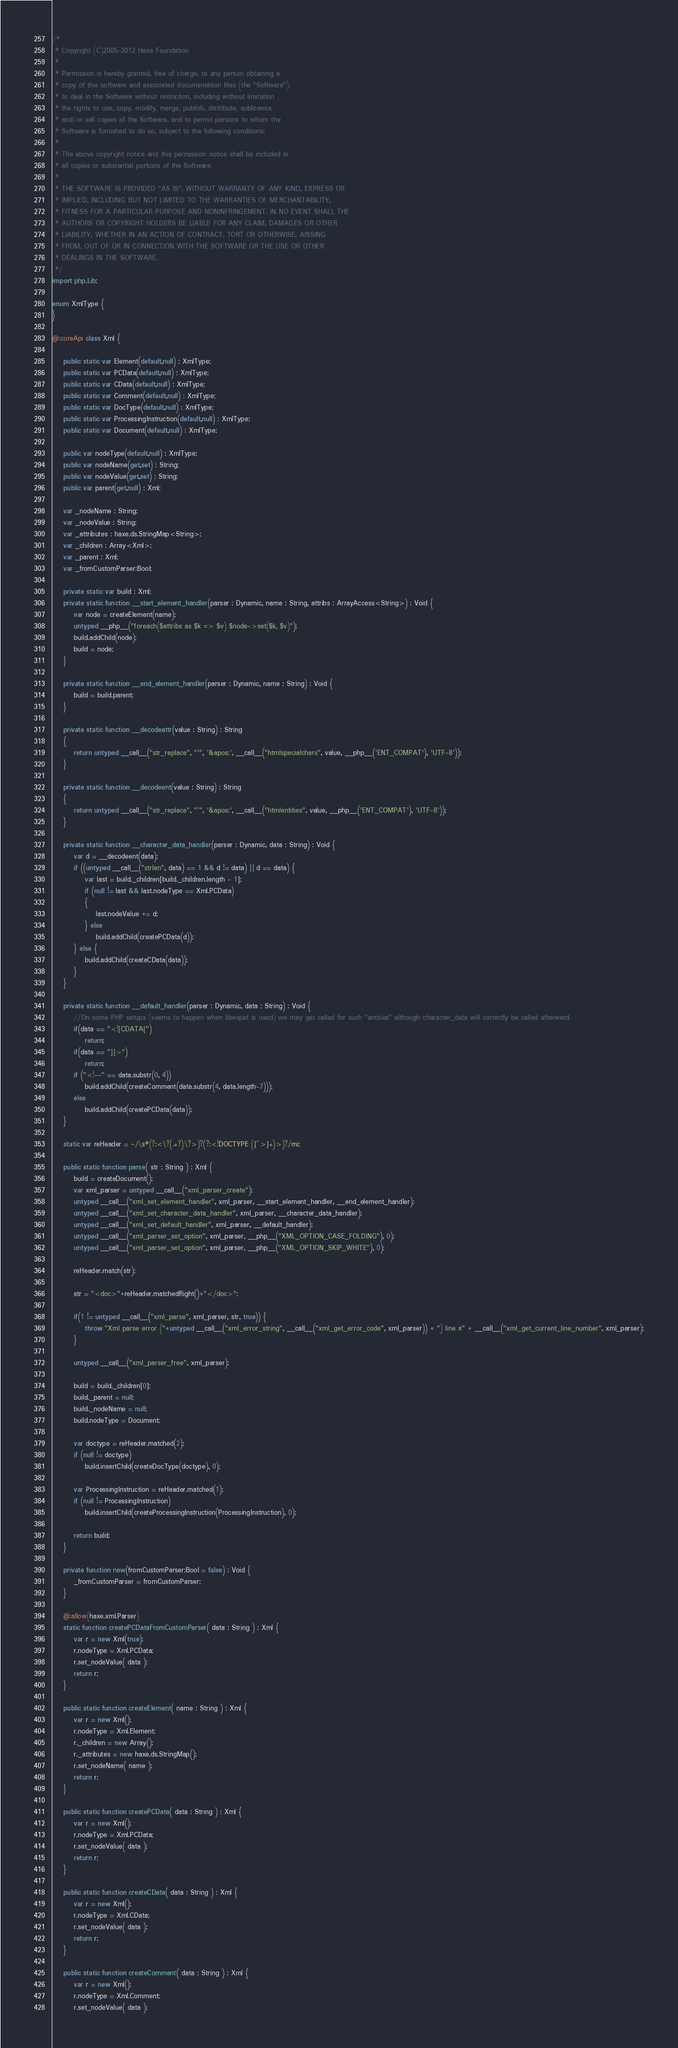<code> <loc_0><loc_0><loc_500><loc_500><_Haxe_>/*
 * Copyright (C)2005-2012 Haxe Foundation
 *
 * Permission is hereby granted, free of charge, to any person obtaining a
 * copy of this software and associated documentation files (the "Software"),
 * to deal in the Software without restriction, including without limitation
 * the rights to use, copy, modify, merge, publish, distribute, sublicense,
 * and/or sell copies of the Software, and to permit persons to whom the
 * Software is furnished to do so, subject to the following conditions:
 *
 * The above copyright notice and this permission notice shall be included in
 * all copies or substantial portions of the Software.
 *
 * THE SOFTWARE IS PROVIDED "AS IS", WITHOUT WARRANTY OF ANY KIND, EXPRESS OR
 * IMPLIED, INCLUDING BUT NOT LIMITED TO THE WARRANTIES OF MERCHANTABILITY,
 * FITNESS FOR A PARTICULAR PURPOSE AND NONINFRINGEMENT. IN NO EVENT SHALL THE
 * AUTHORS OR COPYRIGHT HOLDERS BE LIABLE FOR ANY CLAIM, DAMAGES OR OTHER
 * LIABILITY, WHETHER IN AN ACTION OF CONTRACT, TORT OR OTHERWISE, ARISING
 * FROM, OUT OF OR IN CONNECTION WITH THE SOFTWARE OR THE USE OR OTHER
 * DEALINGS IN THE SOFTWARE.
 */
import php.Lib;

enum XmlType {
}

@:coreApi class Xml {

	public static var Element(default,null) : XmlType;
	public static var PCData(default,null) : XmlType;
	public static var CData(default,null) : XmlType;
	public static var Comment(default,null) : XmlType;
	public static var DocType(default,null) : XmlType;
	public static var ProcessingInstruction(default,null) : XmlType;
	public static var Document(default,null) : XmlType;

	public var nodeType(default,null) : XmlType;
	public var nodeName(get,set) : String;
	public var nodeValue(get,set) : String;
	public var parent(get,null) : Xml;

	var _nodeName : String;
	var _nodeValue : String;
	var _attributes : haxe.ds.StringMap<String>;
	var _children : Array<Xml>;
	var _parent : Xml;
	var _fromCustomParser:Bool;

	private static var build : Xml;
	private static function __start_element_handler(parser : Dynamic, name : String, attribs : ArrayAccess<String>) : Void {
		var node = createElement(name);
		untyped __php__("foreach($attribs as $k => $v) $node->set($k, $v)");
		build.addChild(node);
		build = node;
	}

	private static function __end_element_handler(parser : Dynamic, name : String) : Void {
		build = build.parent;
	}

	private static function __decodeattr(value : String) : String
	{
		return untyped __call__("str_replace", "'", '&apos;', __call__("htmlspecialchars", value, __php__('ENT_COMPAT'), 'UTF-8'));
	}

	private static function __decodeent(value : String) : String
	{
		return untyped __call__("str_replace", "'", '&apos;', __call__("htmlentities", value, __php__('ENT_COMPAT'), 'UTF-8'));
	}

	private static function __character_data_handler(parser : Dynamic, data : String) : Void {
		var d = __decodeent(data);
		if ((untyped __call__("strlen", data) == 1 && d != data) || d == data) {
			var last = build._children[build._children.length - 1];
			if (null != last && last.nodeType == Xml.PCData)
			{
				last.nodeValue += d;
			} else
				build.addChild(createPCData(d));
		} else {
			build.addChild(createCData(data));
		}
	}

	private static function __default_handler(parser : Dynamic, data : String) : Void {
		//On some PHP setups (seems to happen when libexpat is used) we may get called for such "entities" although character_data will correctly be called afterward.
		if(data == "<![CDATA[")
			return;
		if(data == "]]>")
			return;
		if ("<!--" == data.substr(0, 4))
			build.addChild(createComment(data.substr(4, data.length-7)));
		else
			build.addChild(createPCData(data));
	}

	static var reHeader = ~/\s*(?:<\?(.+?)\?>)?(?:<!DOCTYPE ([^>]+)>)?/mi;

	public static function parse( str : String ) : Xml {
		build = createDocument();
		var xml_parser = untyped __call__("xml_parser_create");
		untyped __call__("xml_set_element_handler", xml_parser, __start_element_handler, __end_element_handler);
		untyped __call__("xml_set_character_data_handler", xml_parser, __character_data_handler);
		untyped __call__("xml_set_default_handler", xml_parser, __default_handler);
		untyped __call__("xml_parser_set_option", xml_parser, __php__("XML_OPTION_CASE_FOLDING"), 0);
		untyped __call__("xml_parser_set_option", xml_parser, __php__("XML_OPTION_SKIP_WHITE"), 0);

		reHeader.match(str);

		str = "<doc>"+reHeader.matchedRight()+"</doc>";

		if(1 != untyped __call__("xml_parse", xml_parser, str, true)) {
			throw "Xml parse error ("+untyped __call__("xml_error_string", __call__("xml_get_error_code", xml_parser)) + ") line #" + __call__("xml_get_current_line_number", xml_parser);
		}

		untyped __call__("xml_parser_free", xml_parser);

		build = build._children[0];
		build._parent = null;
		build._nodeName = null;
		build.nodeType = Document;

		var doctype = reHeader.matched(2);
		if (null != doctype)
			build.insertChild(createDocType(doctype), 0);

		var ProcessingInstruction = reHeader.matched(1);
		if (null != ProcessingInstruction)
			build.insertChild(createProcessingInstruction(ProcessingInstruction), 0);

		return build;
	}

	private function new(fromCustomParser:Bool = false) : Void {
		_fromCustomParser = fromCustomParser;
	}

	@:allow(haxe.xml.Parser)
	static function createPCDataFromCustomParser( data : String ) : Xml {
		var r = new Xml(true);
		r.nodeType = Xml.PCData;
		r.set_nodeValue( data );
		return r;
	}

	public static function createElement( name : String ) : Xml {
		var r = new Xml();
		r.nodeType = Xml.Element;
		r._children = new Array();
		r._attributes = new haxe.ds.StringMap();
		r.set_nodeName( name );
		return r;
	}

	public static function createPCData( data : String ) : Xml {
		var r = new Xml();
		r.nodeType = Xml.PCData;
		r.set_nodeValue( data );
		return r;
	}

	public static function createCData( data : String ) : Xml {
		var r = new Xml();
		r.nodeType = Xml.CData;
		r.set_nodeValue( data );
		return r;
	}

	public static function createComment( data : String ) : Xml {
		var r = new Xml();
		r.nodeType = Xml.Comment;
		r.set_nodeValue( data );</code> 